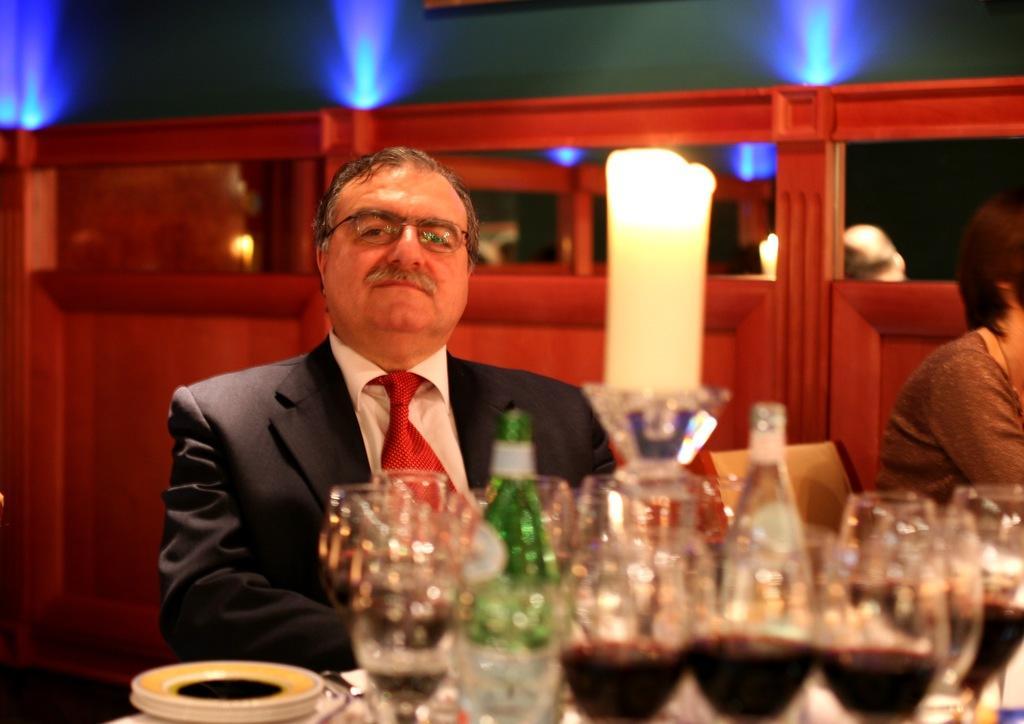In one or two sentences, can you explain what this image depicts? In front of the picture, we see a table on which the plates, glasses containing the liquid and the glass bottles are placed. Behind that, we see a man in the white shirt and the black blazer is sitting on the chair. He is smiling and he might be posing for the photo. On the right side, we see a woman is sitting on the chair. In the background, we see a wall in brown color. At the top, we see the blue color lights and a wall in green color. 